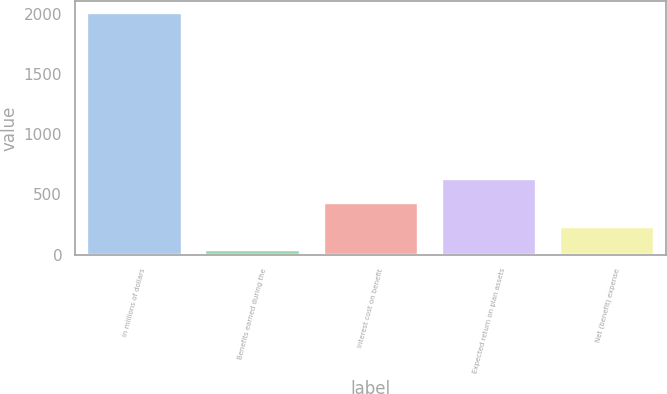<chart> <loc_0><loc_0><loc_500><loc_500><bar_chart><fcel>In millions of dollars<fcel>Benefits earned during the<fcel>Interest cost on benefit<fcel>Expected return on plan assets<fcel>Net (benefit) expense<nl><fcel>2008<fcel>36<fcel>430.4<fcel>627.6<fcel>233.2<nl></chart> 